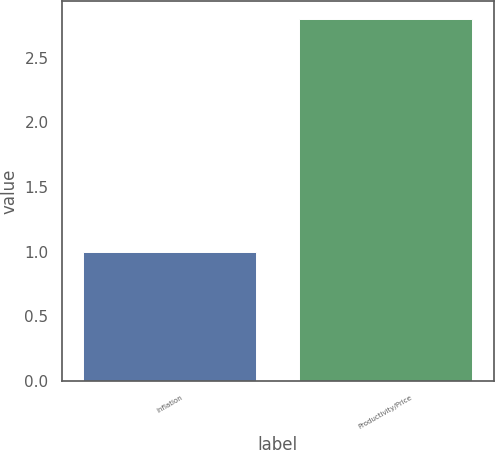Convert chart to OTSL. <chart><loc_0><loc_0><loc_500><loc_500><bar_chart><fcel>Inflation<fcel>Productivity/Price<nl><fcel>1<fcel>2.8<nl></chart> 